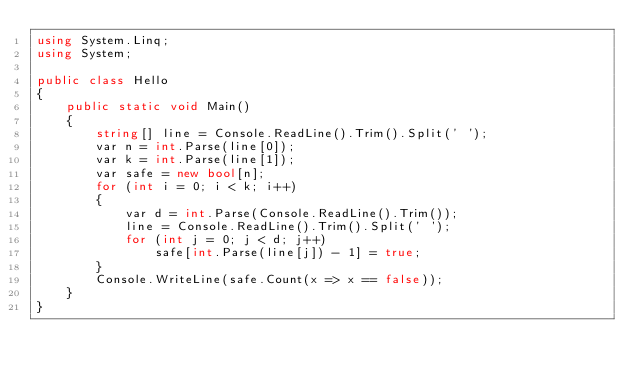<code> <loc_0><loc_0><loc_500><loc_500><_C#_>using System.Linq;
using System;

public class Hello
{
    public static void Main()
    {
        string[] line = Console.ReadLine().Trim().Split(' ');
        var n = int.Parse(line[0]);
        var k = int.Parse(line[1]);
        var safe = new bool[n];
        for (int i = 0; i < k; i++)
        {
            var d = int.Parse(Console.ReadLine().Trim());
            line = Console.ReadLine().Trim().Split(' ');
            for (int j = 0; j < d; j++)
                safe[int.Parse(line[j]) - 1] = true;
        }
        Console.WriteLine(safe.Count(x => x == false));
    }
}
</code> 